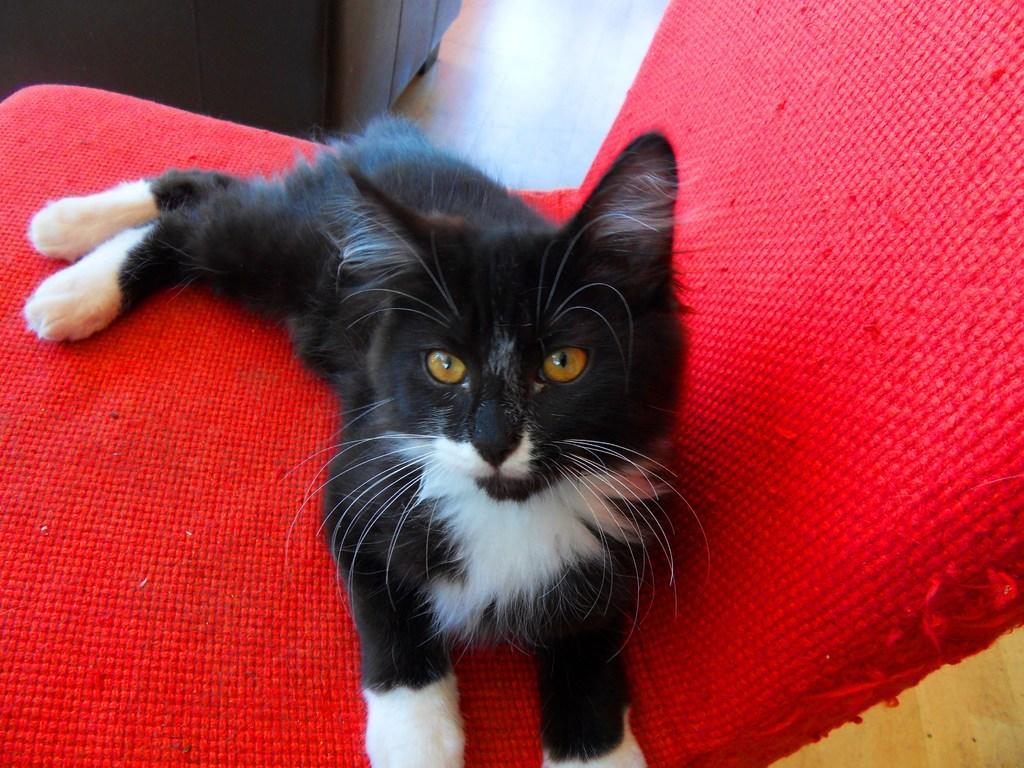What type of animal is in the image? There is a black cat in the image. What is the cat doing in the image? The black cat is lying on a red chair. Is the snail driving the red chair in the image? There is no snail present in the image, and the red chair is not being driven by any animal or person. 